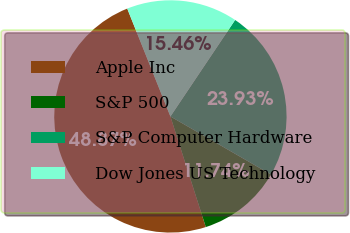<chart> <loc_0><loc_0><loc_500><loc_500><pie_chart><fcel>Apple Inc<fcel>S&P 500<fcel>S&P Computer Hardware<fcel>Dow Jones US Technology<nl><fcel>48.87%<fcel>11.74%<fcel>23.93%<fcel>15.46%<nl></chart> 